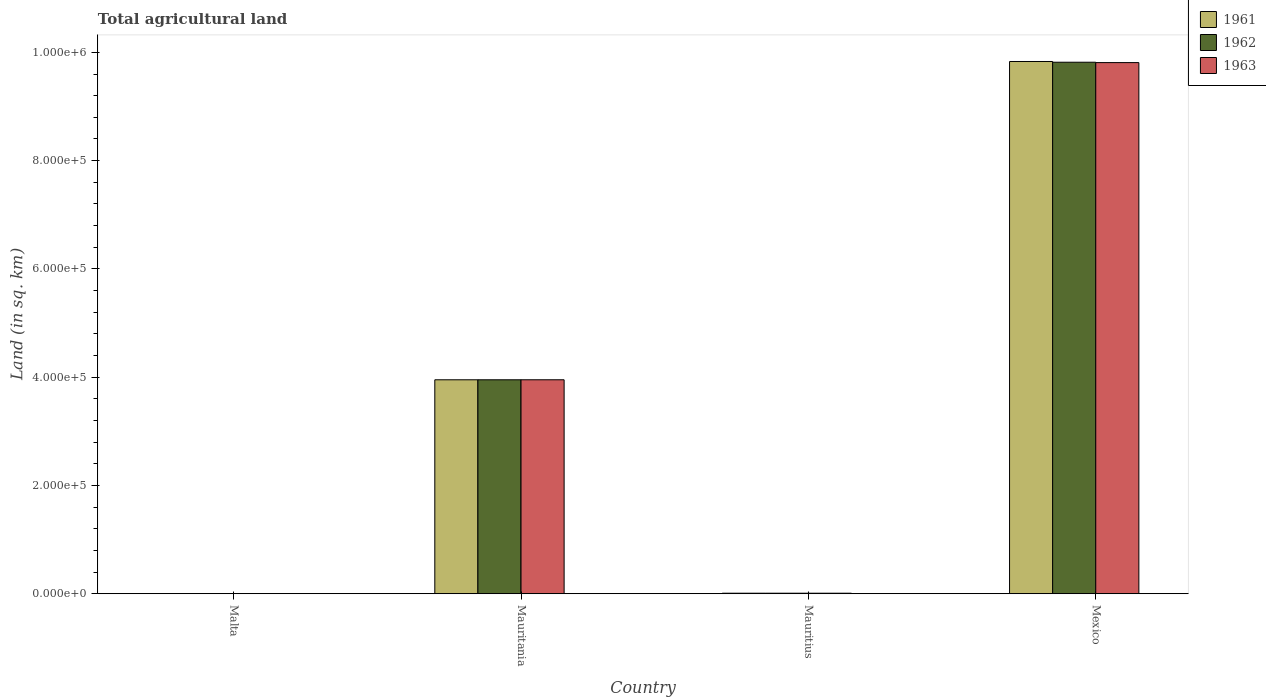How many different coloured bars are there?
Your response must be concise. 3. Are the number of bars on each tick of the X-axis equal?
Your answer should be very brief. Yes. How many bars are there on the 2nd tick from the right?
Your answer should be compact. 3. What is the label of the 3rd group of bars from the left?
Provide a short and direct response. Mauritius. What is the total agricultural land in 1961 in Mexico?
Give a very brief answer. 9.83e+05. Across all countries, what is the maximum total agricultural land in 1961?
Provide a succinct answer. 9.83e+05. Across all countries, what is the minimum total agricultural land in 1963?
Offer a very short reply. 160. In which country was the total agricultural land in 1961 minimum?
Ensure brevity in your answer.  Malta. What is the total total agricultural land in 1962 in the graph?
Your response must be concise. 1.38e+06. What is the difference between the total agricultural land in 1963 in Mauritania and that in Mexico?
Provide a succinct answer. -5.86e+05. What is the difference between the total agricultural land in 1963 in Malta and the total agricultural land in 1961 in Mauritania?
Keep it short and to the point. -3.95e+05. What is the average total agricultural land in 1963 per country?
Make the answer very short. 3.44e+05. What is the difference between the total agricultural land of/in 1963 and total agricultural land of/in 1962 in Malta?
Ensure brevity in your answer.  -10. In how many countries, is the total agricultural land in 1963 greater than 760000 sq.km?
Keep it short and to the point. 1. What is the ratio of the total agricultural land in 1962 in Malta to that in Mauritius?
Your answer should be compact. 0.17. Is the difference between the total agricultural land in 1963 in Mauritania and Mexico greater than the difference between the total agricultural land in 1962 in Mauritania and Mexico?
Your response must be concise. Yes. What is the difference between the highest and the second highest total agricultural land in 1961?
Offer a very short reply. 5.88e+05. What is the difference between the highest and the lowest total agricultural land in 1963?
Offer a very short reply. 9.81e+05. Is the sum of the total agricultural land in 1961 in Malta and Mexico greater than the maximum total agricultural land in 1963 across all countries?
Provide a succinct answer. Yes. What does the 2nd bar from the left in Mauritius represents?
Make the answer very short. 1962. How many bars are there?
Offer a terse response. 12. Are the values on the major ticks of Y-axis written in scientific E-notation?
Provide a succinct answer. Yes. Does the graph contain grids?
Make the answer very short. No. Where does the legend appear in the graph?
Offer a very short reply. Top right. How many legend labels are there?
Keep it short and to the point. 3. How are the legend labels stacked?
Provide a short and direct response. Vertical. What is the title of the graph?
Make the answer very short. Total agricultural land. Does "1972" appear as one of the legend labels in the graph?
Your answer should be compact. No. What is the label or title of the X-axis?
Your response must be concise. Country. What is the label or title of the Y-axis?
Provide a succinct answer. Land (in sq. km). What is the Land (in sq. km) in 1961 in Malta?
Your answer should be very brief. 180. What is the Land (in sq. km) in 1962 in Malta?
Your response must be concise. 170. What is the Land (in sq. km) of 1963 in Malta?
Offer a terse response. 160. What is the Land (in sq. km) of 1961 in Mauritania?
Your response must be concise. 3.95e+05. What is the Land (in sq. km) in 1962 in Mauritania?
Your response must be concise. 3.95e+05. What is the Land (in sq. km) of 1963 in Mauritania?
Give a very brief answer. 3.95e+05. What is the Land (in sq. km) of 1961 in Mauritius?
Your answer should be compact. 990. What is the Land (in sq. km) in 1963 in Mauritius?
Provide a short and direct response. 1000. What is the Land (in sq. km) of 1961 in Mexico?
Keep it short and to the point. 9.83e+05. What is the Land (in sq. km) in 1962 in Mexico?
Offer a terse response. 9.82e+05. What is the Land (in sq. km) of 1963 in Mexico?
Offer a very short reply. 9.81e+05. Across all countries, what is the maximum Land (in sq. km) of 1961?
Your response must be concise. 9.83e+05. Across all countries, what is the maximum Land (in sq. km) in 1962?
Your response must be concise. 9.82e+05. Across all countries, what is the maximum Land (in sq. km) in 1963?
Make the answer very short. 9.81e+05. Across all countries, what is the minimum Land (in sq. km) of 1961?
Ensure brevity in your answer.  180. Across all countries, what is the minimum Land (in sq. km) in 1962?
Your answer should be very brief. 170. Across all countries, what is the minimum Land (in sq. km) of 1963?
Make the answer very short. 160. What is the total Land (in sq. km) in 1961 in the graph?
Provide a succinct answer. 1.38e+06. What is the total Land (in sq. km) in 1962 in the graph?
Your answer should be compact. 1.38e+06. What is the total Land (in sq. km) in 1963 in the graph?
Offer a terse response. 1.38e+06. What is the difference between the Land (in sq. km) of 1961 in Malta and that in Mauritania?
Your answer should be very brief. -3.95e+05. What is the difference between the Land (in sq. km) of 1962 in Malta and that in Mauritania?
Offer a very short reply. -3.95e+05. What is the difference between the Land (in sq. km) in 1963 in Malta and that in Mauritania?
Give a very brief answer. -3.95e+05. What is the difference between the Land (in sq. km) in 1961 in Malta and that in Mauritius?
Your answer should be compact. -810. What is the difference between the Land (in sq. km) in 1962 in Malta and that in Mauritius?
Give a very brief answer. -830. What is the difference between the Land (in sq. km) of 1963 in Malta and that in Mauritius?
Offer a terse response. -840. What is the difference between the Land (in sq. km) of 1961 in Malta and that in Mexico?
Offer a very short reply. -9.83e+05. What is the difference between the Land (in sq. km) of 1962 in Malta and that in Mexico?
Keep it short and to the point. -9.82e+05. What is the difference between the Land (in sq. km) in 1963 in Malta and that in Mexico?
Offer a very short reply. -9.81e+05. What is the difference between the Land (in sq. km) in 1961 in Mauritania and that in Mauritius?
Offer a very short reply. 3.94e+05. What is the difference between the Land (in sq. km) of 1962 in Mauritania and that in Mauritius?
Ensure brevity in your answer.  3.94e+05. What is the difference between the Land (in sq. km) of 1963 in Mauritania and that in Mauritius?
Your response must be concise. 3.94e+05. What is the difference between the Land (in sq. km) in 1961 in Mauritania and that in Mexico?
Keep it short and to the point. -5.88e+05. What is the difference between the Land (in sq. km) of 1962 in Mauritania and that in Mexico?
Ensure brevity in your answer.  -5.87e+05. What is the difference between the Land (in sq. km) in 1963 in Mauritania and that in Mexico?
Provide a short and direct response. -5.86e+05. What is the difference between the Land (in sq. km) of 1961 in Mauritius and that in Mexico?
Ensure brevity in your answer.  -9.82e+05. What is the difference between the Land (in sq. km) in 1962 in Mauritius and that in Mexico?
Offer a very short reply. -9.81e+05. What is the difference between the Land (in sq. km) in 1963 in Mauritius and that in Mexico?
Offer a terse response. -9.80e+05. What is the difference between the Land (in sq. km) in 1961 in Malta and the Land (in sq. km) in 1962 in Mauritania?
Your answer should be compact. -3.95e+05. What is the difference between the Land (in sq. km) in 1961 in Malta and the Land (in sq. km) in 1963 in Mauritania?
Make the answer very short. -3.95e+05. What is the difference between the Land (in sq. km) in 1962 in Malta and the Land (in sq. km) in 1963 in Mauritania?
Provide a succinct answer. -3.95e+05. What is the difference between the Land (in sq. km) of 1961 in Malta and the Land (in sq. km) of 1962 in Mauritius?
Offer a very short reply. -820. What is the difference between the Land (in sq. km) of 1961 in Malta and the Land (in sq. km) of 1963 in Mauritius?
Your answer should be very brief. -820. What is the difference between the Land (in sq. km) of 1962 in Malta and the Land (in sq. km) of 1963 in Mauritius?
Give a very brief answer. -830. What is the difference between the Land (in sq. km) in 1961 in Malta and the Land (in sq. km) in 1962 in Mexico?
Provide a succinct answer. -9.82e+05. What is the difference between the Land (in sq. km) in 1961 in Malta and the Land (in sq. km) in 1963 in Mexico?
Make the answer very short. -9.81e+05. What is the difference between the Land (in sq. km) of 1962 in Malta and the Land (in sq. km) of 1963 in Mexico?
Your answer should be compact. -9.81e+05. What is the difference between the Land (in sq. km) of 1961 in Mauritania and the Land (in sq. km) of 1962 in Mauritius?
Give a very brief answer. 3.94e+05. What is the difference between the Land (in sq. km) in 1961 in Mauritania and the Land (in sq. km) in 1963 in Mauritius?
Ensure brevity in your answer.  3.94e+05. What is the difference between the Land (in sq. km) in 1962 in Mauritania and the Land (in sq. km) in 1963 in Mauritius?
Offer a very short reply. 3.94e+05. What is the difference between the Land (in sq. km) in 1961 in Mauritania and the Land (in sq. km) in 1962 in Mexico?
Your answer should be very brief. -5.87e+05. What is the difference between the Land (in sq. km) in 1961 in Mauritania and the Land (in sq. km) in 1963 in Mexico?
Your answer should be compact. -5.86e+05. What is the difference between the Land (in sq. km) of 1962 in Mauritania and the Land (in sq. km) of 1963 in Mexico?
Your response must be concise. -5.86e+05. What is the difference between the Land (in sq. km) of 1961 in Mauritius and the Land (in sq. km) of 1962 in Mexico?
Your response must be concise. -9.81e+05. What is the difference between the Land (in sq. km) of 1961 in Mauritius and the Land (in sq. km) of 1963 in Mexico?
Give a very brief answer. -9.80e+05. What is the difference between the Land (in sq. km) in 1962 in Mauritius and the Land (in sq. km) in 1963 in Mexico?
Make the answer very short. -9.80e+05. What is the average Land (in sq. km) of 1961 per country?
Your response must be concise. 3.45e+05. What is the average Land (in sq. km) in 1962 per country?
Keep it short and to the point. 3.45e+05. What is the average Land (in sq. km) in 1963 per country?
Provide a succinct answer. 3.44e+05. What is the difference between the Land (in sq. km) of 1962 and Land (in sq. km) of 1963 in Malta?
Offer a very short reply. 10. What is the difference between the Land (in sq. km) in 1961 and Land (in sq. km) in 1962 in Mauritania?
Provide a succinct answer. 0. What is the difference between the Land (in sq. km) in 1961 and Land (in sq. km) in 1963 in Mauritania?
Provide a succinct answer. -10. What is the difference between the Land (in sq. km) of 1962 and Land (in sq. km) of 1963 in Mauritania?
Offer a terse response. -10. What is the difference between the Land (in sq. km) in 1962 and Land (in sq. km) in 1963 in Mauritius?
Your answer should be very brief. 0. What is the difference between the Land (in sq. km) in 1961 and Land (in sq. km) in 1962 in Mexico?
Your response must be concise. 1370. What is the difference between the Land (in sq. km) of 1961 and Land (in sq. km) of 1963 in Mexico?
Make the answer very short. 2070. What is the difference between the Land (in sq. km) of 1962 and Land (in sq. km) of 1963 in Mexico?
Keep it short and to the point. 700. What is the ratio of the Land (in sq. km) in 1962 in Malta to that in Mauritania?
Your response must be concise. 0. What is the ratio of the Land (in sq. km) in 1963 in Malta to that in Mauritania?
Offer a terse response. 0. What is the ratio of the Land (in sq. km) of 1961 in Malta to that in Mauritius?
Your response must be concise. 0.18. What is the ratio of the Land (in sq. km) in 1962 in Malta to that in Mauritius?
Offer a terse response. 0.17. What is the ratio of the Land (in sq. km) in 1963 in Malta to that in Mauritius?
Make the answer very short. 0.16. What is the ratio of the Land (in sq. km) in 1961 in Malta to that in Mexico?
Offer a very short reply. 0. What is the ratio of the Land (in sq. km) in 1963 in Malta to that in Mexico?
Keep it short and to the point. 0. What is the ratio of the Land (in sq. km) in 1961 in Mauritania to that in Mauritius?
Your answer should be compact. 399.21. What is the ratio of the Land (in sq. km) in 1962 in Mauritania to that in Mauritius?
Your answer should be compact. 395.22. What is the ratio of the Land (in sq. km) in 1963 in Mauritania to that in Mauritius?
Keep it short and to the point. 395.23. What is the ratio of the Land (in sq. km) in 1961 in Mauritania to that in Mexico?
Offer a terse response. 0.4. What is the ratio of the Land (in sq. km) of 1962 in Mauritania to that in Mexico?
Your answer should be compact. 0.4. What is the ratio of the Land (in sq. km) in 1963 in Mauritania to that in Mexico?
Provide a succinct answer. 0.4. What is the ratio of the Land (in sq. km) in 1963 in Mauritius to that in Mexico?
Offer a terse response. 0. What is the difference between the highest and the second highest Land (in sq. km) in 1961?
Offer a terse response. 5.88e+05. What is the difference between the highest and the second highest Land (in sq. km) in 1962?
Give a very brief answer. 5.87e+05. What is the difference between the highest and the second highest Land (in sq. km) in 1963?
Provide a short and direct response. 5.86e+05. What is the difference between the highest and the lowest Land (in sq. km) of 1961?
Ensure brevity in your answer.  9.83e+05. What is the difference between the highest and the lowest Land (in sq. km) of 1962?
Ensure brevity in your answer.  9.82e+05. What is the difference between the highest and the lowest Land (in sq. km) in 1963?
Your answer should be compact. 9.81e+05. 